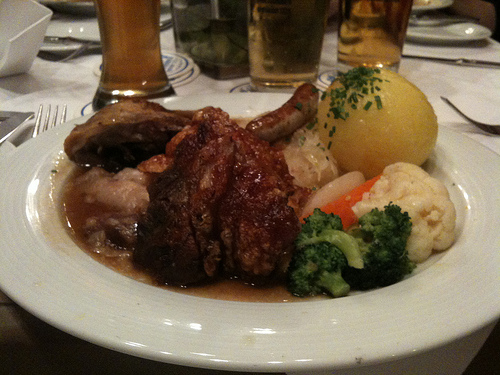<image>
Is there a fork on the plate? No. The fork is not positioned on the plate. They may be near each other, but the fork is not supported by or resting on top of the plate. Is the fork to the left of the sausage? Yes. From this viewpoint, the fork is positioned to the left side relative to the sausage. 